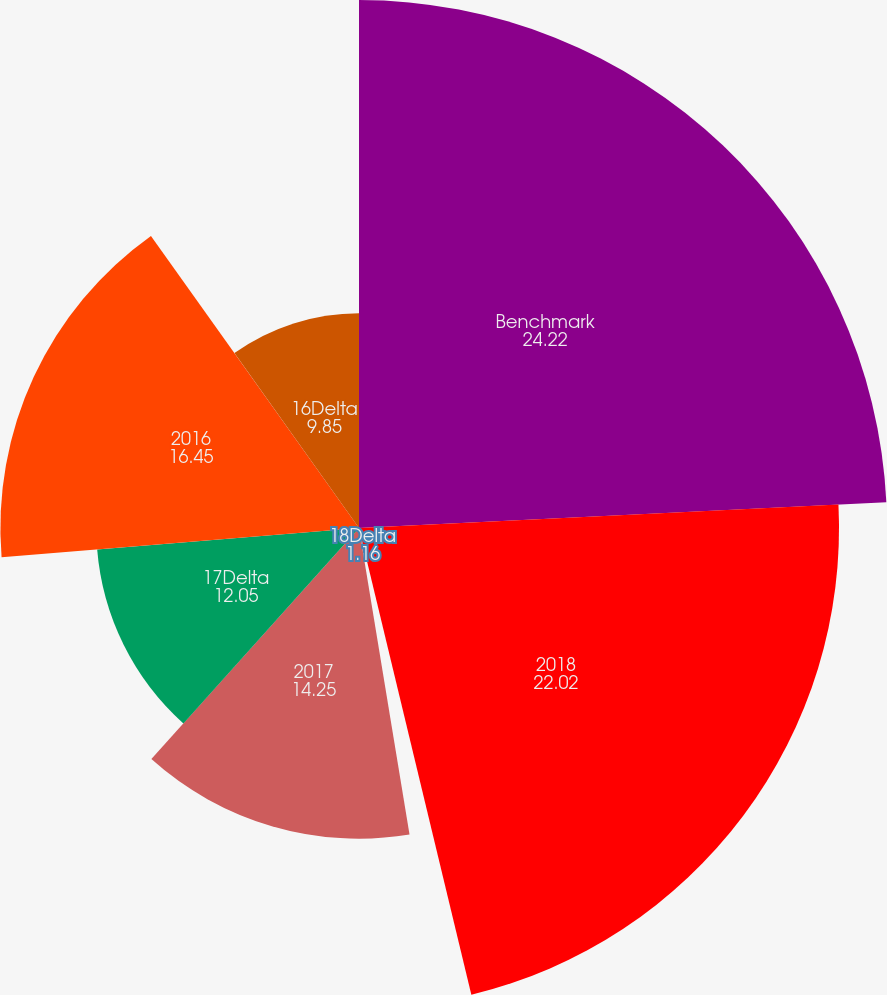<chart> <loc_0><loc_0><loc_500><loc_500><pie_chart><fcel>Benchmark<fcel>2018<fcel>18Delta<fcel>2017<fcel>17Delta<fcel>2016<fcel>16Delta<nl><fcel>24.22%<fcel>22.02%<fcel>1.16%<fcel>14.25%<fcel>12.05%<fcel>16.45%<fcel>9.85%<nl></chart> 